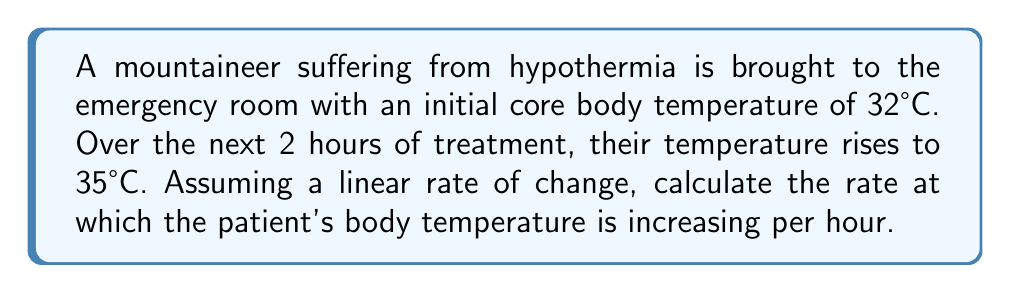Give your solution to this math problem. To solve this problem, we'll use the formula for the rate of change:

$$ \text{Rate of change} = \frac{\text{Change in y}}{\text{Change in x}} $$

Step 1: Identify the change in body temperature (y).
Initial temperature = 32°C
Final temperature = 35°C
Change in temperature = $35°C - 32°C = 3°C$

Step 2: Identify the change in time (x).
Time elapsed = 2 hours

Step 3: Apply the rate of change formula.
$$ \text{Rate of change} = \frac{3°C}{2 \text{ hours}} = 1.5°C/\text{hour} $$

Therefore, the patient's body temperature is increasing at a rate of 1.5°C per hour.
Answer: $1.5°C/\text{hour}$ 